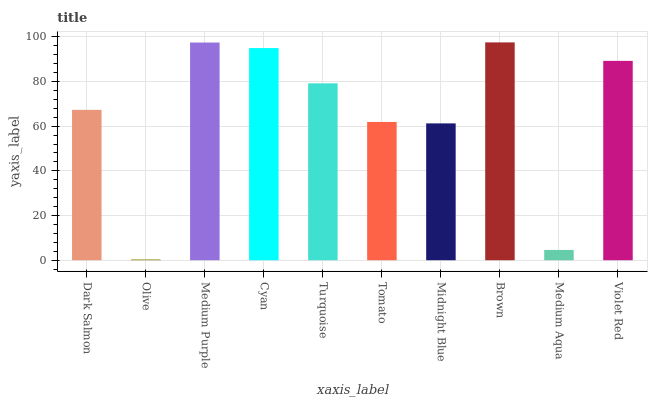Is Medium Purple the minimum?
Answer yes or no. No. Is Medium Purple the maximum?
Answer yes or no. No. Is Medium Purple greater than Olive?
Answer yes or no. Yes. Is Olive less than Medium Purple?
Answer yes or no. Yes. Is Olive greater than Medium Purple?
Answer yes or no. No. Is Medium Purple less than Olive?
Answer yes or no. No. Is Turquoise the high median?
Answer yes or no. Yes. Is Dark Salmon the low median?
Answer yes or no. Yes. Is Cyan the high median?
Answer yes or no. No. Is Midnight Blue the low median?
Answer yes or no. No. 